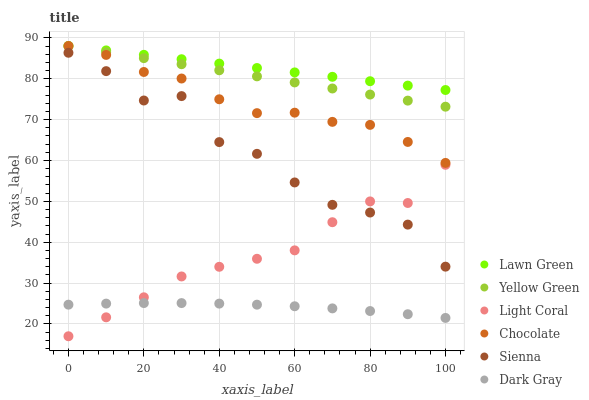Does Dark Gray have the minimum area under the curve?
Answer yes or no. Yes. Does Lawn Green have the maximum area under the curve?
Answer yes or no. Yes. Does Yellow Green have the minimum area under the curve?
Answer yes or no. No. Does Yellow Green have the maximum area under the curve?
Answer yes or no. No. Is Lawn Green the smoothest?
Answer yes or no. Yes. Is Sienna the roughest?
Answer yes or no. Yes. Is Yellow Green the smoothest?
Answer yes or no. No. Is Yellow Green the roughest?
Answer yes or no. No. Does Light Coral have the lowest value?
Answer yes or no. Yes. Does Yellow Green have the lowest value?
Answer yes or no. No. Does Chocolate have the highest value?
Answer yes or no. Yes. Does Light Coral have the highest value?
Answer yes or no. No. Is Light Coral less than Yellow Green?
Answer yes or no. Yes. Is Yellow Green greater than Light Coral?
Answer yes or no. Yes. Does Lawn Green intersect Chocolate?
Answer yes or no. Yes. Is Lawn Green less than Chocolate?
Answer yes or no. No. Is Lawn Green greater than Chocolate?
Answer yes or no. No. Does Light Coral intersect Yellow Green?
Answer yes or no. No. 